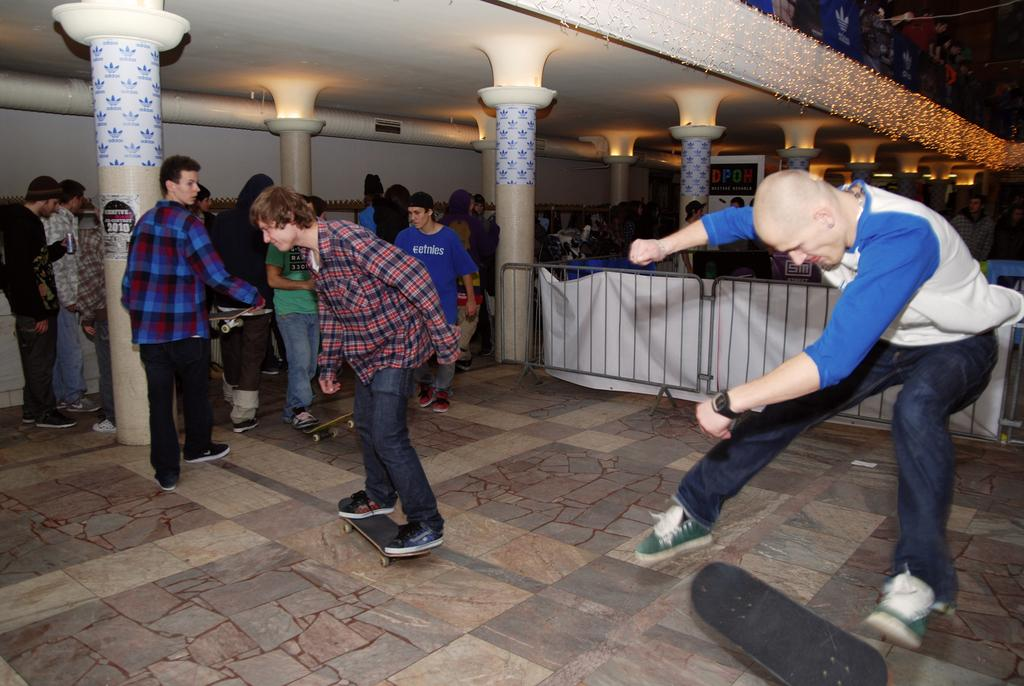What activity are the people in the image engaged in? The people in the image are skating on skateboards. On what surface are they skating? The skating is taking place on a floor. What can be seen in the background of the image? There are people standing, pillars, railing, and lights in the background of the image. What type of spark can be seen coming from the trucks in the image? There are no trucks present in the image, so there is no spark to observe. 